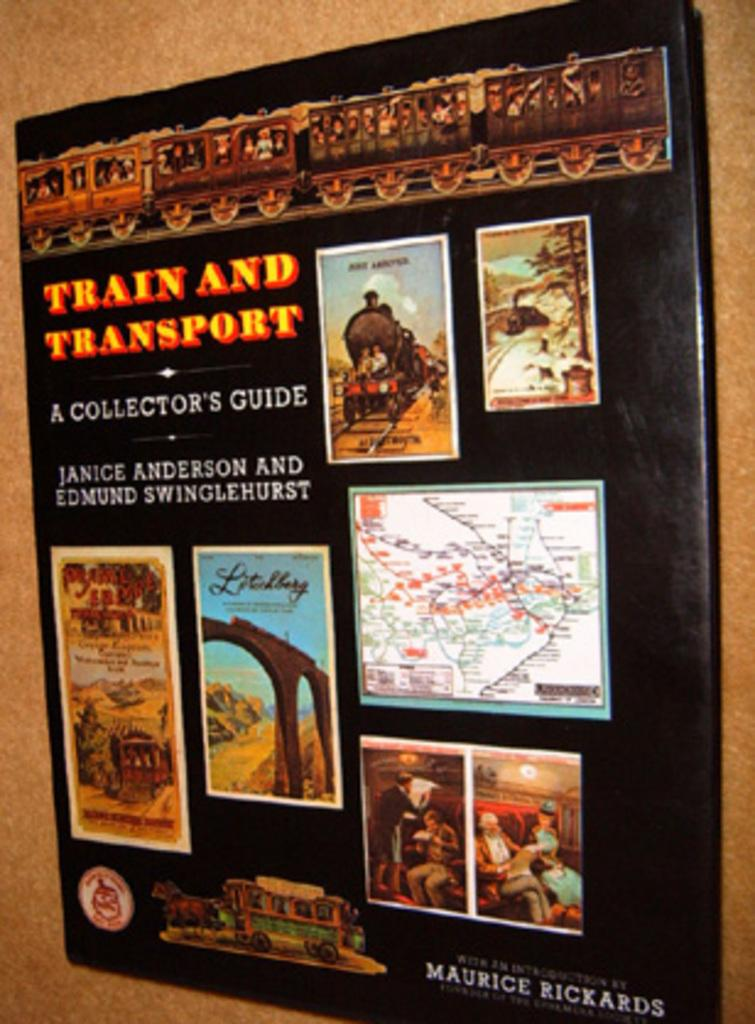<image>
Describe the image concisely. The Train and Transport collector's guide has images of trains and maps on it. 